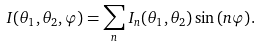<formula> <loc_0><loc_0><loc_500><loc_500>I ( \theta _ { 1 } , \theta _ { 2 } , \varphi ) = \sum _ { n } I _ { n } ( \theta _ { 1 } , \theta _ { 2 } ) \sin { ( n \varphi ) } .</formula> 